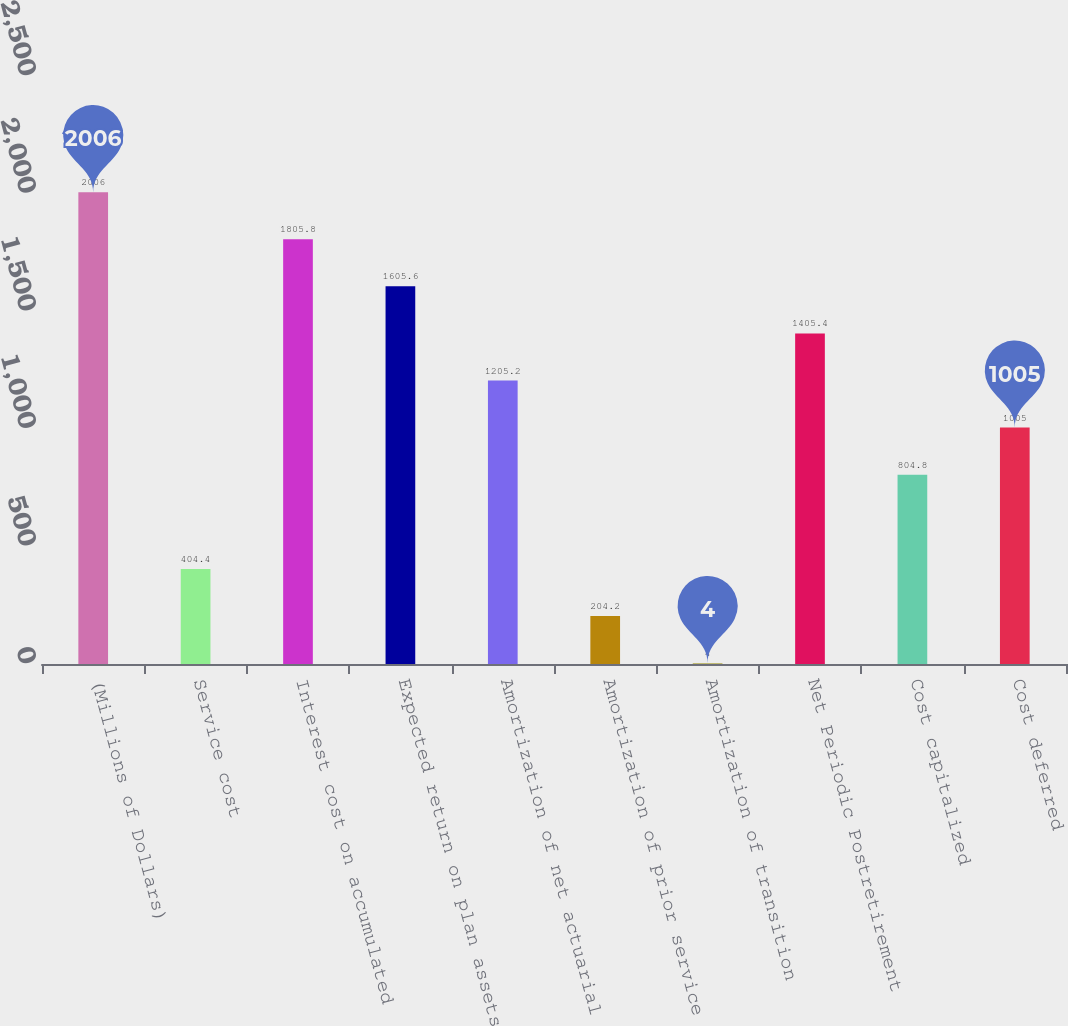Convert chart. <chart><loc_0><loc_0><loc_500><loc_500><bar_chart><fcel>(Millions of Dollars)<fcel>Service cost<fcel>Interest cost on accumulated<fcel>Expected return on plan assets<fcel>Amortization of net actuarial<fcel>Amortization of prior service<fcel>Amortization of transition<fcel>Net Periodic Postretirement<fcel>Cost capitalized<fcel>Cost deferred<nl><fcel>2006<fcel>404.4<fcel>1805.8<fcel>1605.6<fcel>1205.2<fcel>204.2<fcel>4<fcel>1405.4<fcel>804.8<fcel>1005<nl></chart> 